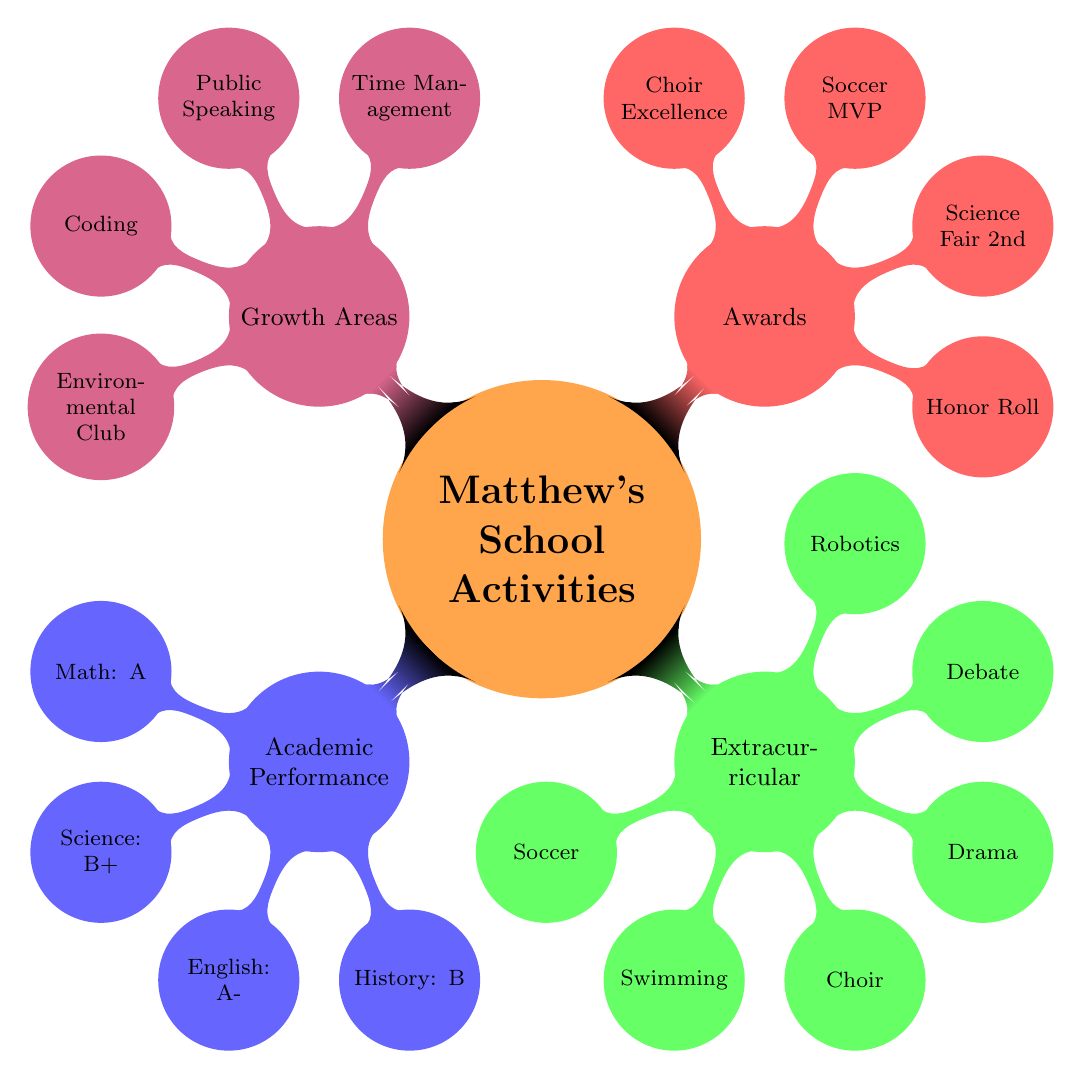What grades did Matthew receive in Mathematics? The diagram directly states that Matthew received an "A" in Mathematics under the Academic Performance section.
Answer: A How many extracurricular activities is Matthew involved in? By counting the activities listed under Extracurricular Activities, we find that there are six activities (Soccer, Swimming, Choir, Drama, Debate, Robotics).
Answer: 6 What award did Matthew receive for academics? The diagram lists "Honor Roll" and "Science Fair 2nd Place" under the Awards section for Academics. The first one is simpler and a more common award received for academics.
Answer: Honor Roll Which growth area concerns public speaking? The diagram under the Growth Areas section specifically mentions "Public Speaking" as an area that needs improvement.
Answer: Public Speaking What is one new interest Matthew has developed? Under the New Interests in the Growth Areas section, "Coding" is listed as one of Matthew's new interests. This shows a dual interest in technology and growth.
Answer: Coding What subject did Matthew score a B+ in? The Grades section states that Matthew received a B+ specifically in Science. This is a direct reference to his academic performance.
Answer: Science Which artistic activity does Matthew participate in? The Extracurricular section lists "School Choir" and "Drama Club" under Artistic activities, showing that both are involved, but focusing on one, "School Choir" can be taken as an example.
Answer: School Choir How many awards has Matthew received in sports? From the Awards section, Matthew has received two sports-related awards: "Soccer MVP" and "Swimming Achievement Award," thus totaling two awards in sports.
Answer: 2 What is one area Matthew needs improvement in? The Growth Areas section under Need Improvement lists "Time Management," indicating this is one area he is seeking to improve.
Answer: Time Management 